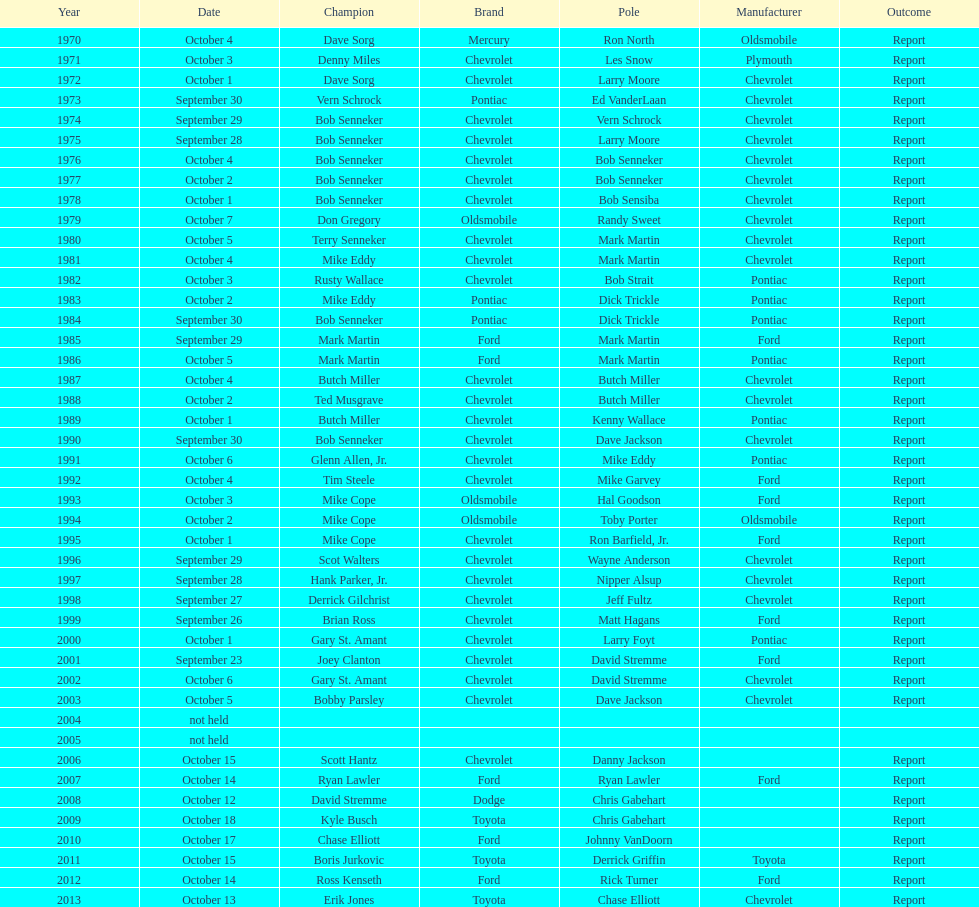Which month held the most winchester 400 races? October. 